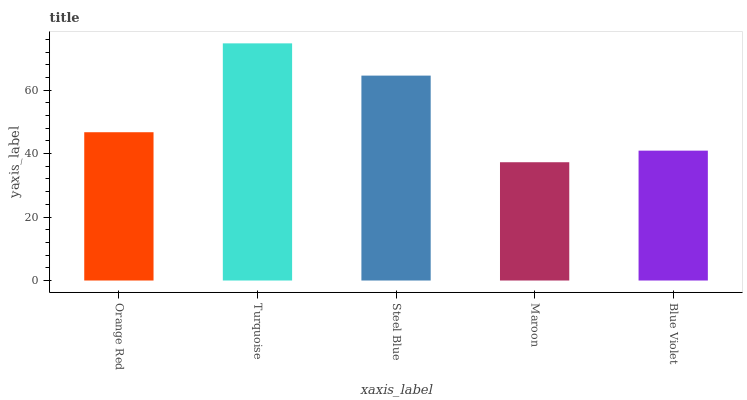Is Maroon the minimum?
Answer yes or no. Yes. Is Turquoise the maximum?
Answer yes or no. Yes. Is Steel Blue the minimum?
Answer yes or no. No. Is Steel Blue the maximum?
Answer yes or no. No. Is Turquoise greater than Steel Blue?
Answer yes or no. Yes. Is Steel Blue less than Turquoise?
Answer yes or no. Yes. Is Steel Blue greater than Turquoise?
Answer yes or no. No. Is Turquoise less than Steel Blue?
Answer yes or no. No. Is Orange Red the high median?
Answer yes or no. Yes. Is Orange Red the low median?
Answer yes or no. Yes. Is Blue Violet the high median?
Answer yes or no. No. Is Blue Violet the low median?
Answer yes or no. No. 